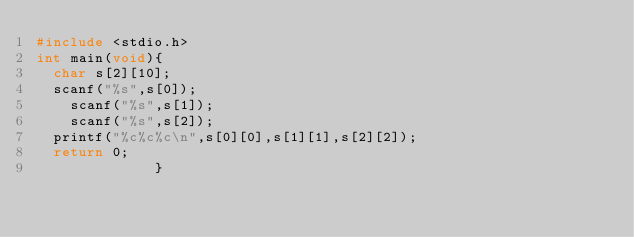Convert code to text. <code><loc_0><loc_0><loc_500><loc_500><_C_>#include <stdio.h>
int main(void){
  char s[2][10];
  scanf("%s",s[0]);
    scanf("%s",s[1]);
    scanf("%s",s[2]);
  printf("%c%c%c\n",s[0][0],s[1][1],s[2][2]);
  return 0;
              }</code> 